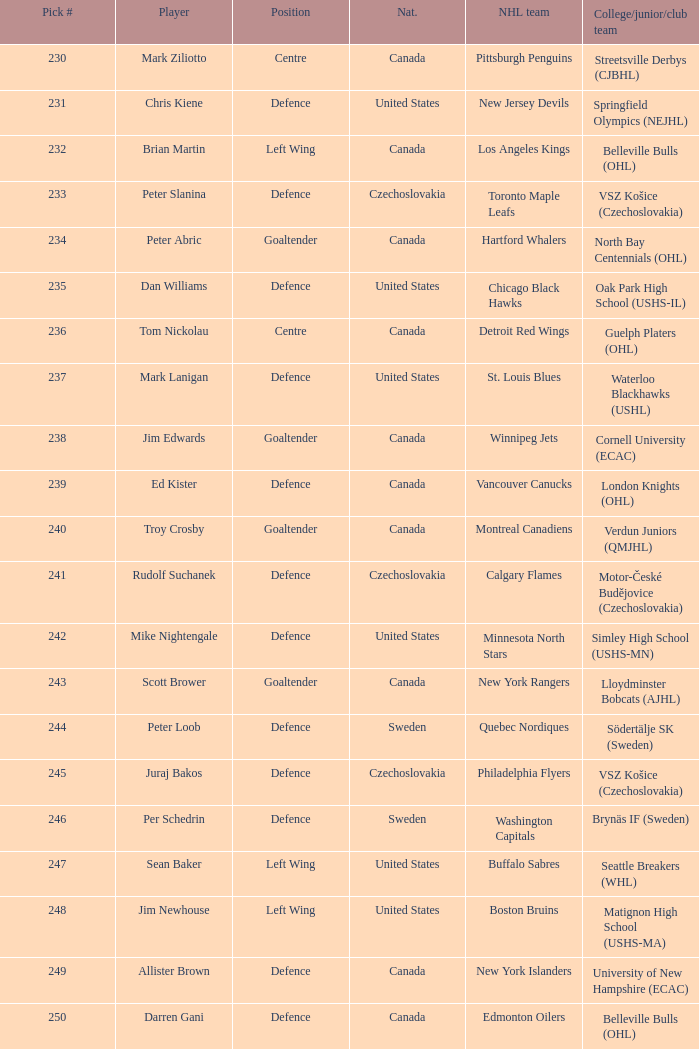Which draft number did the new jersey devils get? 231.0. 